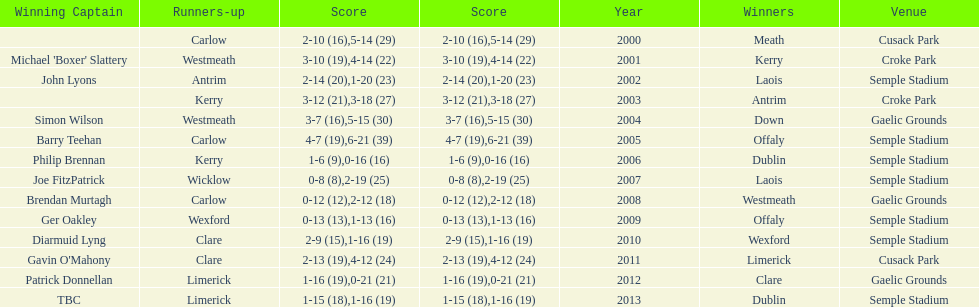Which team was the previous winner before dublin in 2013? Clare. Would you mind parsing the complete table? {'header': ['Winning Captain', 'Runners-up', 'Score', 'Score', 'Year', 'Winners', 'Venue'], 'rows': [['', 'Carlow', '2-10 (16)', '5-14 (29)', '2000', 'Meath', 'Cusack Park'], ["Michael 'Boxer' Slattery", 'Westmeath', '3-10 (19)', '4-14 (22)', '2001', 'Kerry', 'Croke Park'], ['John Lyons', 'Antrim', '2-14 (20)', '1-20 (23)', '2002', 'Laois', 'Semple Stadium'], ['', 'Kerry', '3-12 (21)', '3-18 (27)', '2003', 'Antrim', 'Croke Park'], ['Simon Wilson', 'Westmeath', '3-7 (16)', '5-15 (30)', '2004', 'Down', 'Gaelic Grounds'], ['Barry Teehan', 'Carlow', '4-7 (19)', '6-21 (39)', '2005', 'Offaly', 'Semple Stadium'], ['Philip Brennan', 'Kerry', '1-6 (9)', '0-16 (16)', '2006', 'Dublin', 'Semple Stadium'], ['Joe FitzPatrick', 'Wicklow', '0-8 (8)', '2-19 (25)', '2007', 'Laois', 'Semple Stadium'], ['Brendan Murtagh', 'Carlow', '0-12 (12)', '2-12 (18)', '2008', 'Westmeath', 'Gaelic Grounds'], ['Ger Oakley', 'Wexford', '0-13 (13)', '1-13 (16)', '2009', 'Offaly', 'Semple Stadium'], ['Diarmuid Lyng', 'Clare', '2-9 (15)', '1-16 (19)', '2010', 'Wexford', 'Semple Stadium'], ["Gavin O'Mahony", 'Clare', '2-13 (19)', '4-12 (24)', '2011', 'Limerick', 'Cusack Park'], ['Patrick Donnellan', 'Limerick', '1-16 (19)', '0-21 (21)', '2012', 'Clare', 'Gaelic Grounds'], ['TBC', 'Limerick', '1-15 (18)', '1-16 (19)', '2013', 'Dublin', 'Semple Stadium']]} 